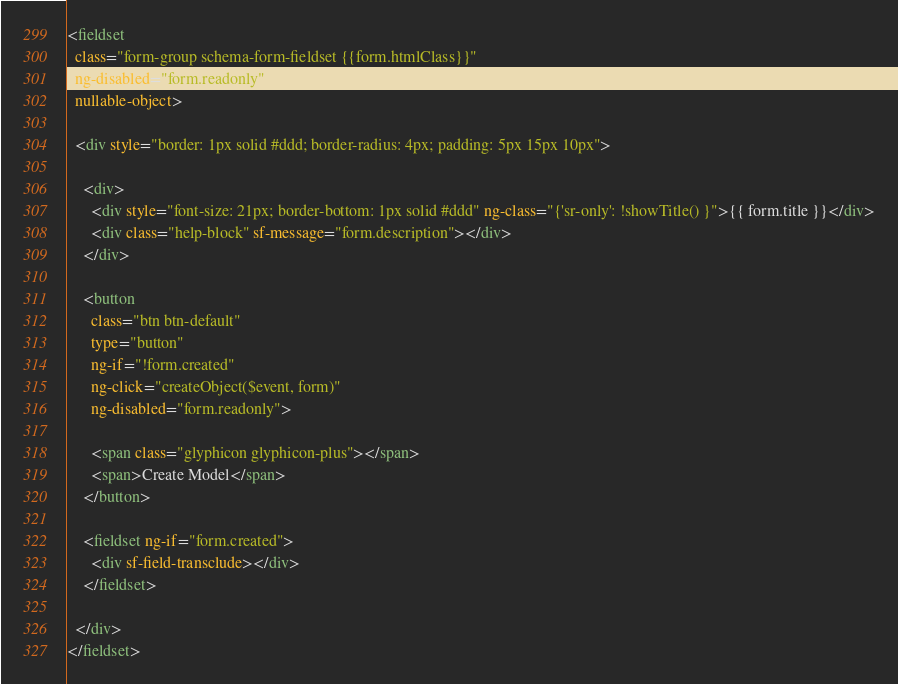Convert code to text. <code><loc_0><loc_0><loc_500><loc_500><_HTML_><fieldset
  class="form-group schema-form-fieldset {{form.htmlClass}}"
  ng-disabled="form.readonly"
  nullable-object>

  <div style="border: 1px solid #ddd; border-radius: 4px; padding: 5px 15px 10px">

    <div>
      <div style="font-size: 21px; border-bottom: 1px solid #ddd" ng-class="{'sr-only': !showTitle() }">{{ form.title }}</div>
      <div class="help-block" sf-message="form.description"></div>
    </div>

    <button
      class="btn btn-default"
      type="button"
      ng-if="!form.created"
      ng-click="createObject($event, form)"
      ng-disabled="form.readonly">

      <span class="glyphicon glyphicon-plus"></span>
      <span>Create Model</span>
    </button>

    <fieldset ng-if="form.created">
      <div sf-field-transclude></div>
    </fieldset>

  </div>
</fieldset>
</code> 